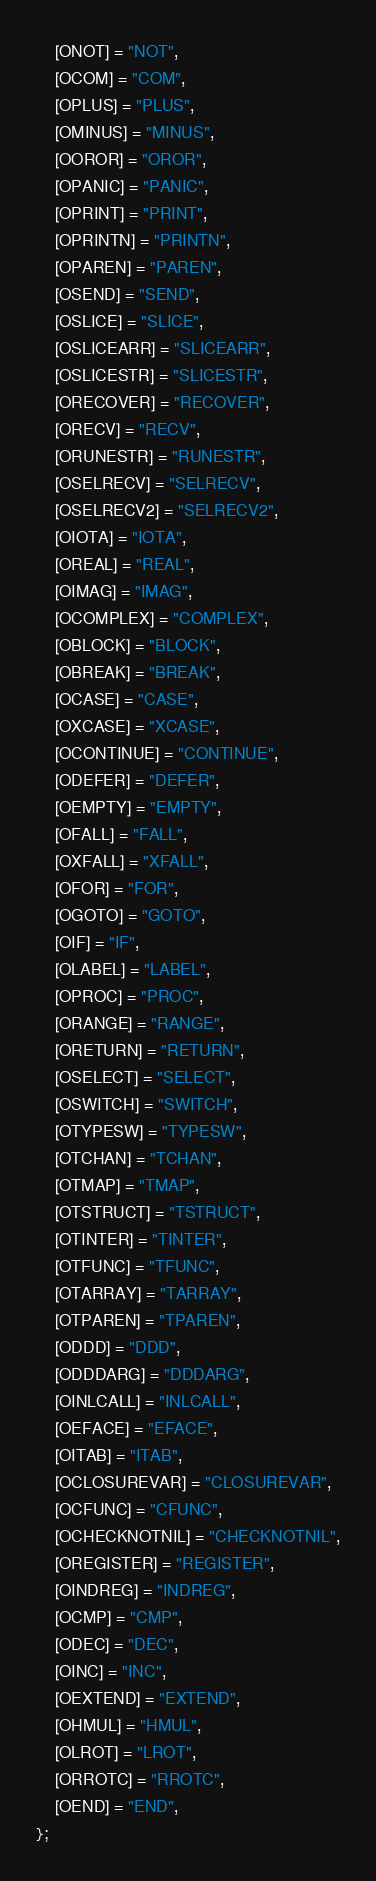<code> <loc_0><loc_0><loc_500><loc_500><_C_>	[ONOT] = "NOT",
	[OCOM] = "COM",
	[OPLUS] = "PLUS",
	[OMINUS] = "MINUS",
	[OOROR] = "OROR",
	[OPANIC] = "PANIC",
	[OPRINT] = "PRINT",
	[OPRINTN] = "PRINTN",
	[OPAREN] = "PAREN",
	[OSEND] = "SEND",
	[OSLICE] = "SLICE",
	[OSLICEARR] = "SLICEARR",
	[OSLICESTR] = "SLICESTR",
	[ORECOVER] = "RECOVER",
	[ORECV] = "RECV",
	[ORUNESTR] = "RUNESTR",
	[OSELRECV] = "SELRECV",
	[OSELRECV2] = "SELRECV2",
	[OIOTA] = "IOTA",
	[OREAL] = "REAL",
	[OIMAG] = "IMAG",
	[OCOMPLEX] = "COMPLEX",
	[OBLOCK] = "BLOCK",
	[OBREAK] = "BREAK",
	[OCASE] = "CASE",
	[OXCASE] = "XCASE",
	[OCONTINUE] = "CONTINUE",
	[ODEFER] = "DEFER",
	[OEMPTY] = "EMPTY",
	[OFALL] = "FALL",
	[OXFALL] = "XFALL",
	[OFOR] = "FOR",
	[OGOTO] = "GOTO",
	[OIF] = "IF",
	[OLABEL] = "LABEL",
	[OPROC] = "PROC",
	[ORANGE] = "RANGE",
	[ORETURN] = "RETURN",
	[OSELECT] = "SELECT",
	[OSWITCH] = "SWITCH",
	[OTYPESW] = "TYPESW",
	[OTCHAN] = "TCHAN",
	[OTMAP] = "TMAP",
	[OTSTRUCT] = "TSTRUCT",
	[OTINTER] = "TINTER",
	[OTFUNC] = "TFUNC",
	[OTARRAY] = "TARRAY",
	[OTPAREN] = "TPAREN",
	[ODDD] = "DDD",
	[ODDDARG] = "DDDARG",
	[OINLCALL] = "INLCALL",
	[OEFACE] = "EFACE",
	[OITAB] = "ITAB",
	[OCLOSUREVAR] = "CLOSUREVAR",
	[OCFUNC] = "CFUNC",
	[OCHECKNOTNIL] = "CHECKNOTNIL",
	[OREGISTER] = "REGISTER",
	[OINDREG] = "INDREG",
	[OCMP] = "CMP",
	[ODEC] = "DEC",
	[OINC] = "INC",
	[OEXTEND] = "EXTEND",
	[OHMUL] = "HMUL",
	[OLROT] = "LROT",
	[ORROTC] = "RROTC",
	[OEND] = "END",
};
</code> 